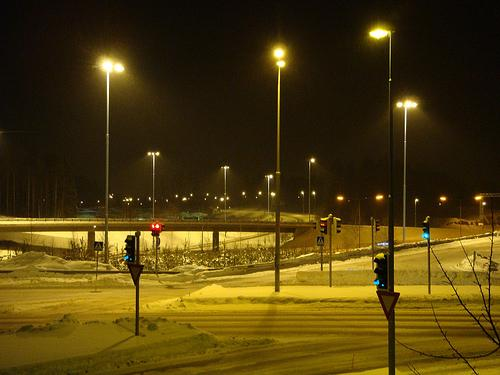How is the weather in the image and what state are the streetlights in? The weather appears to be snowy, and there are three streetlights side by side that are illuminated. What is the state of the traffic light in the stop position? The traffic light is showing a red light in the stop position. Identify the type of sign that is red and white in the image. A red and white triangular yield sign is in the image. Count the number of green lights that are part of the signal in the snow description. There are two green lights that are part of the signal in the snow. Mention one object in the image that has to do with traffic control. A traffic light in the go position is present in the image. How many light poles in the ground are there in the image? There are ten light poles in the ground in the image. Describe the condition of the branches found in the image. There are barren leafless branches and twig branches near the traffic light in the image. Can you spot any elevated infrastructure in the image? There is an elevated freeway overpass visible in the image. What is the condition of the street in the image, and is there anything distinctive about the plants nearby? The street is covered in snow and there are dry plants on the side of the street. How many red lights in the form of two red lights on a pole are there in the image? There are ten instances of two red lights on a pole in the image. 